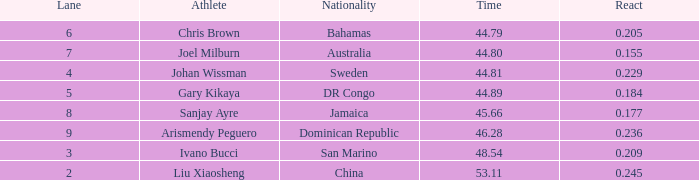245? 0.0. 